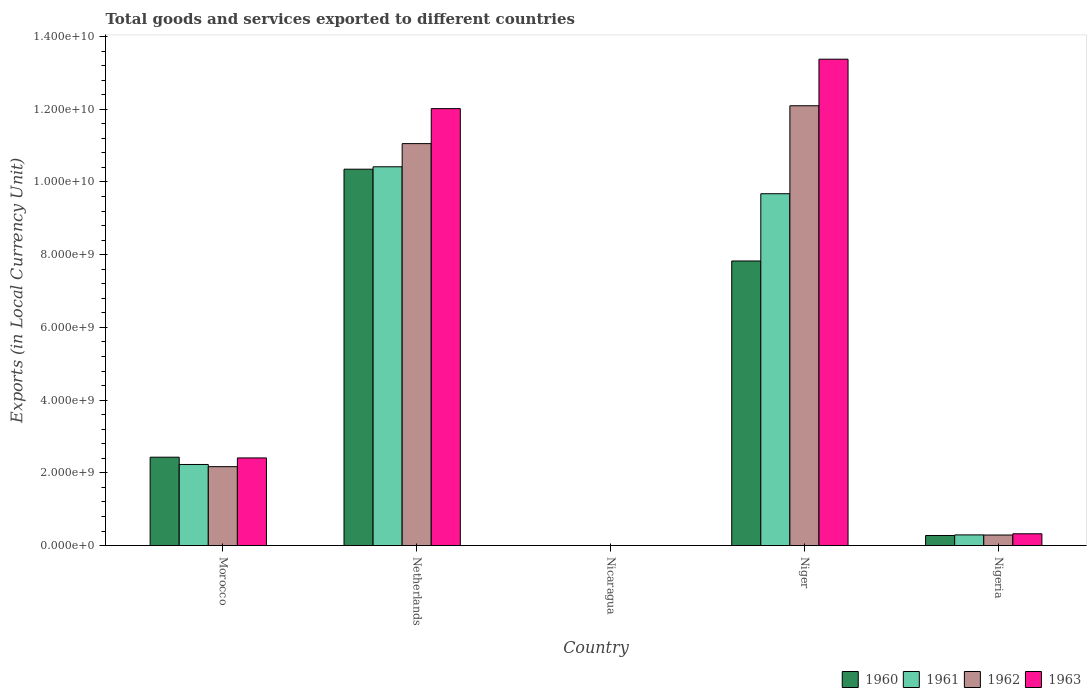How many different coloured bars are there?
Make the answer very short. 4. Are the number of bars per tick equal to the number of legend labels?
Ensure brevity in your answer.  Yes. Are the number of bars on each tick of the X-axis equal?
Ensure brevity in your answer.  Yes. How many bars are there on the 4th tick from the left?
Your response must be concise. 4. How many bars are there on the 3rd tick from the right?
Provide a succinct answer. 4. What is the label of the 5th group of bars from the left?
Offer a very short reply. Nigeria. What is the Amount of goods and services exports in 1961 in Niger?
Give a very brief answer. 9.68e+09. Across all countries, what is the maximum Amount of goods and services exports in 1962?
Ensure brevity in your answer.  1.21e+1. Across all countries, what is the minimum Amount of goods and services exports in 1961?
Make the answer very short. 0.12. In which country was the Amount of goods and services exports in 1963 maximum?
Your response must be concise. Niger. In which country was the Amount of goods and services exports in 1963 minimum?
Your answer should be compact. Nicaragua. What is the total Amount of goods and services exports in 1962 in the graph?
Your response must be concise. 2.56e+1. What is the difference between the Amount of goods and services exports in 1961 in Morocco and that in Nigeria?
Provide a short and direct response. 1.94e+09. What is the difference between the Amount of goods and services exports in 1961 in Netherlands and the Amount of goods and services exports in 1963 in Niger?
Your response must be concise. -2.96e+09. What is the average Amount of goods and services exports in 1961 per country?
Your answer should be very brief. 4.52e+09. What is the difference between the Amount of goods and services exports of/in 1962 and Amount of goods and services exports of/in 1960 in Nigeria?
Your answer should be compact. 1.30e+07. What is the ratio of the Amount of goods and services exports in 1963 in Netherlands to that in Nigeria?
Offer a very short reply. 37.1. Is the Amount of goods and services exports in 1961 in Nicaragua less than that in Niger?
Provide a short and direct response. Yes. What is the difference between the highest and the second highest Amount of goods and services exports in 1963?
Your answer should be compact. -1.36e+09. What is the difference between the highest and the lowest Amount of goods and services exports in 1962?
Provide a succinct answer. 1.21e+1. What does the 3rd bar from the right in Morocco represents?
Make the answer very short. 1961. How many bars are there?
Offer a terse response. 20. Are all the bars in the graph horizontal?
Provide a succinct answer. No. How many countries are there in the graph?
Make the answer very short. 5. What is the difference between two consecutive major ticks on the Y-axis?
Your answer should be compact. 2.00e+09. Are the values on the major ticks of Y-axis written in scientific E-notation?
Your answer should be compact. Yes. Does the graph contain any zero values?
Make the answer very short. No. Does the graph contain grids?
Your response must be concise. No. What is the title of the graph?
Give a very brief answer. Total goods and services exported to different countries. Does "1975" appear as one of the legend labels in the graph?
Offer a terse response. No. What is the label or title of the Y-axis?
Offer a terse response. Exports (in Local Currency Unit). What is the Exports (in Local Currency Unit) in 1960 in Morocco?
Your answer should be compact. 2.43e+09. What is the Exports (in Local Currency Unit) of 1961 in Morocco?
Provide a succinct answer. 2.23e+09. What is the Exports (in Local Currency Unit) of 1962 in Morocco?
Your answer should be compact. 2.17e+09. What is the Exports (in Local Currency Unit) of 1963 in Morocco?
Provide a succinct answer. 2.41e+09. What is the Exports (in Local Currency Unit) of 1960 in Netherlands?
Provide a short and direct response. 1.04e+1. What is the Exports (in Local Currency Unit) of 1961 in Netherlands?
Provide a succinct answer. 1.04e+1. What is the Exports (in Local Currency Unit) of 1962 in Netherlands?
Your response must be concise. 1.11e+1. What is the Exports (in Local Currency Unit) in 1963 in Netherlands?
Your answer should be compact. 1.20e+1. What is the Exports (in Local Currency Unit) in 1960 in Nicaragua?
Provide a succinct answer. 0.11. What is the Exports (in Local Currency Unit) of 1961 in Nicaragua?
Your answer should be very brief. 0.12. What is the Exports (in Local Currency Unit) in 1962 in Nicaragua?
Provide a succinct answer. 0.15. What is the Exports (in Local Currency Unit) in 1963 in Nicaragua?
Offer a terse response. 0.18. What is the Exports (in Local Currency Unit) of 1960 in Niger?
Provide a short and direct response. 7.83e+09. What is the Exports (in Local Currency Unit) of 1961 in Niger?
Your answer should be compact. 9.68e+09. What is the Exports (in Local Currency Unit) in 1962 in Niger?
Your response must be concise. 1.21e+1. What is the Exports (in Local Currency Unit) in 1963 in Niger?
Offer a very short reply. 1.34e+1. What is the Exports (in Local Currency Unit) in 1960 in Nigeria?
Keep it short and to the point. 2.77e+08. What is the Exports (in Local Currency Unit) in 1961 in Nigeria?
Give a very brief answer. 2.93e+08. What is the Exports (in Local Currency Unit) in 1962 in Nigeria?
Your answer should be very brief. 2.90e+08. What is the Exports (in Local Currency Unit) of 1963 in Nigeria?
Your response must be concise. 3.24e+08. Across all countries, what is the maximum Exports (in Local Currency Unit) of 1960?
Your response must be concise. 1.04e+1. Across all countries, what is the maximum Exports (in Local Currency Unit) in 1961?
Offer a very short reply. 1.04e+1. Across all countries, what is the maximum Exports (in Local Currency Unit) of 1962?
Make the answer very short. 1.21e+1. Across all countries, what is the maximum Exports (in Local Currency Unit) in 1963?
Ensure brevity in your answer.  1.34e+1. Across all countries, what is the minimum Exports (in Local Currency Unit) in 1960?
Provide a succinct answer. 0.11. Across all countries, what is the minimum Exports (in Local Currency Unit) of 1961?
Keep it short and to the point. 0.12. Across all countries, what is the minimum Exports (in Local Currency Unit) of 1962?
Offer a terse response. 0.15. Across all countries, what is the minimum Exports (in Local Currency Unit) of 1963?
Offer a terse response. 0.18. What is the total Exports (in Local Currency Unit) of 1960 in the graph?
Ensure brevity in your answer.  2.09e+1. What is the total Exports (in Local Currency Unit) of 1961 in the graph?
Provide a succinct answer. 2.26e+1. What is the total Exports (in Local Currency Unit) in 1962 in the graph?
Make the answer very short. 2.56e+1. What is the total Exports (in Local Currency Unit) of 1963 in the graph?
Offer a terse response. 2.81e+1. What is the difference between the Exports (in Local Currency Unit) in 1960 in Morocco and that in Netherlands?
Provide a succinct answer. -7.92e+09. What is the difference between the Exports (in Local Currency Unit) in 1961 in Morocco and that in Netherlands?
Provide a succinct answer. -8.19e+09. What is the difference between the Exports (in Local Currency Unit) in 1962 in Morocco and that in Netherlands?
Your response must be concise. -8.88e+09. What is the difference between the Exports (in Local Currency Unit) of 1963 in Morocco and that in Netherlands?
Provide a succinct answer. -9.61e+09. What is the difference between the Exports (in Local Currency Unit) of 1960 in Morocco and that in Nicaragua?
Make the answer very short. 2.43e+09. What is the difference between the Exports (in Local Currency Unit) in 1961 in Morocco and that in Nicaragua?
Offer a terse response. 2.23e+09. What is the difference between the Exports (in Local Currency Unit) of 1962 in Morocco and that in Nicaragua?
Keep it short and to the point. 2.17e+09. What is the difference between the Exports (in Local Currency Unit) of 1963 in Morocco and that in Nicaragua?
Offer a very short reply. 2.41e+09. What is the difference between the Exports (in Local Currency Unit) in 1960 in Morocco and that in Niger?
Your response must be concise. -5.40e+09. What is the difference between the Exports (in Local Currency Unit) of 1961 in Morocco and that in Niger?
Ensure brevity in your answer.  -7.45e+09. What is the difference between the Exports (in Local Currency Unit) of 1962 in Morocco and that in Niger?
Ensure brevity in your answer.  -9.92e+09. What is the difference between the Exports (in Local Currency Unit) of 1963 in Morocco and that in Niger?
Ensure brevity in your answer.  -1.10e+1. What is the difference between the Exports (in Local Currency Unit) of 1960 in Morocco and that in Nigeria?
Your answer should be compact. 2.15e+09. What is the difference between the Exports (in Local Currency Unit) of 1961 in Morocco and that in Nigeria?
Give a very brief answer. 1.94e+09. What is the difference between the Exports (in Local Currency Unit) in 1962 in Morocco and that in Nigeria?
Offer a very short reply. 1.88e+09. What is the difference between the Exports (in Local Currency Unit) of 1963 in Morocco and that in Nigeria?
Your answer should be very brief. 2.09e+09. What is the difference between the Exports (in Local Currency Unit) of 1960 in Netherlands and that in Nicaragua?
Make the answer very short. 1.04e+1. What is the difference between the Exports (in Local Currency Unit) in 1961 in Netherlands and that in Nicaragua?
Make the answer very short. 1.04e+1. What is the difference between the Exports (in Local Currency Unit) of 1962 in Netherlands and that in Nicaragua?
Give a very brief answer. 1.11e+1. What is the difference between the Exports (in Local Currency Unit) of 1963 in Netherlands and that in Nicaragua?
Keep it short and to the point. 1.20e+1. What is the difference between the Exports (in Local Currency Unit) of 1960 in Netherlands and that in Niger?
Keep it short and to the point. 2.52e+09. What is the difference between the Exports (in Local Currency Unit) of 1961 in Netherlands and that in Niger?
Offer a very short reply. 7.41e+08. What is the difference between the Exports (in Local Currency Unit) of 1962 in Netherlands and that in Niger?
Your answer should be very brief. -1.04e+09. What is the difference between the Exports (in Local Currency Unit) of 1963 in Netherlands and that in Niger?
Your answer should be very brief. -1.36e+09. What is the difference between the Exports (in Local Currency Unit) in 1960 in Netherlands and that in Nigeria?
Ensure brevity in your answer.  1.01e+1. What is the difference between the Exports (in Local Currency Unit) of 1961 in Netherlands and that in Nigeria?
Give a very brief answer. 1.01e+1. What is the difference between the Exports (in Local Currency Unit) of 1962 in Netherlands and that in Nigeria?
Your response must be concise. 1.08e+1. What is the difference between the Exports (in Local Currency Unit) in 1963 in Netherlands and that in Nigeria?
Provide a short and direct response. 1.17e+1. What is the difference between the Exports (in Local Currency Unit) of 1960 in Nicaragua and that in Niger?
Ensure brevity in your answer.  -7.83e+09. What is the difference between the Exports (in Local Currency Unit) of 1961 in Nicaragua and that in Niger?
Make the answer very short. -9.68e+09. What is the difference between the Exports (in Local Currency Unit) in 1962 in Nicaragua and that in Niger?
Give a very brief answer. -1.21e+1. What is the difference between the Exports (in Local Currency Unit) of 1963 in Nicaragua and that in Niger?
Your response must be concise. -1.34e+1. What is the difference between the Exports (in Local Currency Unit) of 1960 in Nicaragua and that in Nigeria?
Provide a succinct answer. -2.77e+08. What is the difference between the Exports (in Local Currency Unit) in 1961 in Nicaragua and that in Nigeria?
Offer a terse response. -2.93e+08. What is the difference between the Exports (in Local Currency Unit) of 1962 in Nicaragua and that in Nigeria?
Keep it short and to the point. -2.90e+08. What is the difference between the Exports (in Local Currency Unit) of 1963 in Nicaragua and that in Nigeria?
Keep it short and to the point. -3.24e+08. What is the difference between the Exports (in Local Currency Unit) in 1960 in Niger and that in Nigeria?
Your answer should be compact. 7.55e+09. What is the difference between the Exports (in Local Currency Unit) in 1961 in Niger and that in Nigeria?
Keep it short and to the point. 9.38e+09. What is the difference between the Exports (in Local Currency Unit) of 1962 in Niger and that in Nigeria?
Offer a very short reply. 1.18e+1. What is the difference between the Exports (in Local Currency Unit) of 1963 in Niger and that in Nigeria?
Provide a succinct answer. 1.31e+1. What is the difference between the Exports (in Local Currency Unit) of 1960 in Morocco and the Exports (in Local Currency Unit) of 1961 in Netherlands?
Offer a very short reply. -7.99e+09. What is the difference between the Exports (in Local Currency Unit) of 1960 in Morocco and the Exports (in Local Currency Unit) of 1962 in Netherlands?
Your response must be concise. -8.62e+09. What is the difference between the Exports (in Local Currency Unit) of 1960 in Morocco and the Exports (in Local Currency Unit) of 1963 in Netherlands?
Provide a succinct answer. -9.59e+09. What is the difference between the Exports (in Local Currency Unit) in 1961 in Morocco and the Exports (in Local Currency Unit) in 1962 in Netherlands?
Offer a very short reply. -8.82e+09. What is the difference between the Exports (in Local Currency Unit) in 1961 in Morocco and the Exports (in Local Currency Unit) in 1963 in Netherlands?
Offer a very short reply. -9.79e+09. What is the difference between the Exports (in Local Currency Unit) in 1962 in Morocco and the Exports (in Local Currency Unit) in 1963 in Netherlands?
Offer a very short reply. -9.85e+09. What is the difference between the Exports (in Local Currency Unit) of 1960 in Morocco and the Exports (in Local Currency Unit) of 1961 in Nicaragua?
Provide a short and direct response. 2.43e+09. What is the difference between the Exports (in Local Currency Unit) in 1960 in Morocco and the Exports (in Local Currency Unit) in 1962 in Nicaragua?
Give a very brief answer. 2.43e+09. What is the difference between the Exports (in Local Currency Unit) in 1960 in Morocco and the Exports (in Local Currency Unit) in 1963 in Nicaragua?
Keep it short and to the point. 2.43e+09. What is the difference between the Exports (in Local Currency Unit) of 1961 in Morocco and the Exports (in Local Currency Unit) of 1962 in Nicaragua?
Your answer should be very brief. 2.23e+09. What is the difference between the Exports (in Local Currency Unit) in 1961 in Morocco and the Exports (in Local Currency Unit) in 1963 in Nicaragua?
Offer a very short reply. 2.23e+09. What is the difference between the Exports (in Local Currency Unit) in 1962 in Morocco and the Exports (in Local Currency Unit) in 1963 in Nicaragua?
Your answer should be very brief. 2.17e+09. What is the difference between the Exports (in Local Currency Unit) of 1960 in Morocco and the Exports (in Local Currency Unit) of 1961 in Niger?
Give a very brief answer. -7.25e+09. What is the difference between the Exports (in Local Currency Unit) of 1960 in Morocco and the Exports (in Local Currency Unit) of 1962 in Niger?
Provide a succinct answer. -9.66e+09. What is the difference between the Exports (in Local Currency Unit) of 1960 in Morocco and the Exports (in Local Currency Unit) of 1963 in Niger?
Offer a very short reply. -1.09e+1. What is the difference between the Exports (in Local Currency Unit) of 1961 in Morocco and the Exports (in Local Currency Unit) of 1962 in Niger?
Provide a succinct answer. -9.86e+09. What is the difference between the Exports (in Local Currency Unit) of 1961 in Morocco and the Exports (in Local Currency Unit) of 1963 in Niger?
Keep it short and to the point. -1.11e+1. What is the difference between the Exports (in Local Currency Unit) in 1962 in Morocco and the Exports (in Local Currency Unit) in 1963 in Niger?
Provide a succinct answer. -1.12e+1. What is the difference between the Exports (in Local Currency Unit) of 1960 in Morocco and the Exports (in Local Currency Unit) of 1961 in Nigeria?
Your answer should be very brief. 2.14e+09. What is the difference between the Exports (in Local Currency Unit) in 1960 in Morocco and the Exports (in Local Currency Unit) in 1962 in Nigeria?
Ensure brevity in your answer.  2.14e+09. What is the difference between the Exports (in Local Currency Unit) of 1960 in Morocco and the Exports (in Local Currency Unit) of 1963 in Nigeria?
Your answer should be very brief. 2.11e+09. What is the difference between the Exports (in Local Currency Unit) of 1961 in Morocco and the Exports (in Local Currency Unit) of 1962 in Nigeria?
Make the answer very short. 1.94e+09. What is the difference between the Exports (in Local Currency Unit) of 1961 in Morocco and the Exports (in Local Currency Unit) of 1963 in Nigeria?
Offer a very short reply. 1.91e+09. What is the difference between the Exports (in Local Currency Unit) in 1962 in Morocco and the Exports (in Local Currency Unit) in 1963 in Nigeria?
Your answer should be compact. 1.85e+09. What is the difference between the Exports (in Local Currency Unit) in 1960 in Netherlands and the Exports (in Local Currency Unit) in 1961 in Nicaragua?
Provide a short and direct response. 1.04e+1. What is the difference between the Exports (in Local Currency Unit) of 1960 in Netherlands and the Exports (in Local Currency Unit) of 1962 in Nicaragua?
Provide a succinct answer. 1.04e+1. What is the difference between the Exports (in Local Currency Unit) in 1960 in Netherlands and the Exports (in Local Currency Unit) in 1963 in Nicaragua?
Provide a short and direct response. 1.04e+1. What is the difference between the Exports (in Local Currency Unit) in 1961 in Netherlands and the Exports (in Local Currency Unit) in 1962 in Nicaragua?
Ensure brevity in your answer.  1.04e+1. What is the difference between the Exports (in Local Currency Unit) of 1961 in Netherlands and the Exports (in Local Currency Unit) of 1963 in Nicaragua?
Your response must be concise. 1.04e+1. What is the difference between the Exports (in Local Currency Unit) of 1962 in Netherlands and the Exports (in Local Currency Unit) of 1963 in Nicaragua?
Provide a short and direct response. 1.11e+1. What is the difference between the Exports (in Local Currency Unit) of 1960 in Netherlands and the Exports (in Local Currency Unit) of 1961 in Niger?
Provide a succinct answer. 6.75e+08. What is the difference between the Exports (in Local Currency Unit) of 1960 in Netherlands and the Exports (in Local Currency Unit) of 1962 in Niger?
Make the answer very short. -1.74e+09. What is the difference between the Exports (in Local Currency Unit) of 1960 in Netherlands and the Exports (in Local Currency Unit) of 1963 in Niger?
Give a very brief answer. -3.02e+09. What is the difference between the Exports (in Local Currency Unit) of 1961 in Netherlands and the Exports (in Local Currency Unit) of 1962 in Niger?
Your response must be concise. -1.68e+09. What is the difference between the Exports (in Local Currency Unit) in 1961 in Netherlands and the Exports (in Local Currency Unit) in 1963 in Niger?
Make the answer very short. -2.96e+09. What is the difference between the Exports (in Local Currency Unit) in 1962 in Netherlands and the Exports (in Local Currency Unit) in 1963 in Niger?
Provide a succinct answer. -2.32e+09. What is the difference between the Exports (in Local Currency Unit) of 1960 in Netherlands and the Exports (in Local Currency Unit) of 1961 in Nigeria?
Your response must be concise. 1.01e+1. What is the difference between the Exports (in Local Currency Unit) in 1960 in Netherlands and the Exports (in Local Currency Unit) in 1962 in Nigeria?
Your answer should be compact. 1.01e+1. What is the difference between the Exports (in Local Currency Unit) in 1960 in Netherlands and the Exports (in Local Currency Unit) in 1963 in Nigeria?
Make the answer very short. 1.00e+1. What is the difference between the Exports (in Local Currency Unit) in 1961 in Netherlands and the Exports (in Local Currency Unit) in 1962 in Nigeria?
Give a very brief answer. 1.01e+1. What is the difference between the Exports (in Local Currency Unit) of 1961 in Netherlands and the Exports (in Local Currency Unit) of 1963 in Nigeria?
Offer a very short reply. 1.01e+1. What is the difference between the Exports (in Local Currency Unit) in 1962 in Netherlands and the Exports (in Local Currency Unit) in 1963 in Nigeria?
Make the answer very short. 1.07e+1. What is the difference between the Exports (in Local Currency Unit) in 1960 in Nicaragua and the Exports (in Local Currency Unit) in 1961 in Niger?
Provide a succinct answer. -9.68e+09. What is the difference between the Exports (in Local Currency Unit) of 1960 in Nicaragua and the Exports (in Local Currency Unit) of 1962 in Niger?
Offer a very short reply. -1.21e+1. What is the difference between the Exports (in Local Currency Unit) of 1960 in Nicaragua and the Exports (in Local Currency Unit) of 1963 in Niger?
Your answer should be compact. -1.34e+1. What is the difference between the Exports (in Local Currency Unit) of 1961 in Nicaragua and the Exports (in Local Currency Unit) of 1962 in Niger?
Provide a short and direct response. -1.21e+1. What is the difference between the Exports (in Local Currency Unit) in 1961 in Nicaragua and the Exports (in Local Currency Unit) in 1963 in Niger?
Provide a succinct answer. -1.34e+1. What is the difference between the Exports (in Local Currency Unit) of 1962 in Nicaragua and the Exports (in Local Currency Unit) of 1963 in Niger?
Your answer should be compact. -1.34e+1. What is the difference between the Exports (in Local Currency Unit) of 1960 in Nicaragua and the Exports (in Local Currency Unit) of 1961 in Nigeria?
Ensure brevity in your answer.  -2.93e+08. What is the difference between the Exports (in Local Currency Unit) of 1960 in Nicaragua and the Exports (in Local Currency Unit) of 1962 in Nigeria?
Your answer should be compact. -2.90e+08. What is the difference between the Exports (in Local Currency Unit) of 1960 in Nicaragua and the Exports (in Local Currency Unit) of 1963 in Nigeria?
Offer a very short reply. -3.24e+08. What is the difference between the Exports (in Local Currency Unit) in 1961 in Nicaragua and the Exports (in Local Currency Unit) in 1962 in Nigeria?
Your answer should be very brief. -2.90e+08. What is the difference between the Exports (in Local Currency Unit) in 1961 in Nicaragua and the Exports (in Local Currency Unit) in 1963 in Nigeria?
Give a very brief answer. -3.24e+08. What is the difference between the Exports (in Local Currency Unit) of 1962 in Nicaragua and the Exports (in Local Currency Unit) of 1963 in Nigeria?
Ensure brevity in your answer.  -3.24e+08. What is the difference between the Exports (in Local Currency Unit) in 1960 in Niger and the Exports (in Local Currency Unit) in 1961 in Nigeria?
Give a very brief answer. 7.53e+09. What is the difference between the Exports (in Local Currency Unit) in 1960 in Niger and the Exports (in Local Currency Unit) in 1962 in Nigeria?
Offer a very short reply. 7.54e+09. What is the difference between the Exports (in Local Currency Unit) in 1960 in Niger and the Exports (in Local Currency Unit) in 1963 in Nigeria?
Give a very brief answer. 7.50e+09. What is the difference between the Exports (in Local Currency Unit) in 1961 in Niger and the Exports (in Local Currency Unit) in 1962 in Nigeria?
Provide a succinct answer. 9.39e+09. What is the difference between the Exports (in Local Currency Unit) of 1961 in Niger and the Exports (in Local Currency Unit) of 1963 in Nigeria?
Provide a succinct answer. 9.35e+09. What is the difference between the Exports (in Local Currency Unit) of 1962 in Niger and the Exports (in Local Currency Unit) of 1963 in Nigeria?
Provide a succinct answer. 1.18e+1. What is the average Exports (in Local Currency Unit) in 1960 per country?
Make the answer very short. 4.18e+09. What is the average Exports (in Local Currency Unit) in 1961 per country?
Your response must be concise. 4.52e+09. What is the average Exports (in Local Currency Unit) of 1962 per country?
Give a very brief answer. 5.12e+09. What is the average Exports (in Local Currency Unit) of 1963 per country?
Make the answer very short. 5.63e+09. What is the difference between the Exports (in Local Currency Unit) in 1960 and Exports (in Local Currency Unit) in 1962 in Morocco?
Provide a short and direct response. 2.60e+08. What is the difference between the Exports (in Local Currency Unit) in 1960 and Exports (in Local Currency Unit) in 1963 in Morocco?
Offer a very short reply. 2.00e+07. What is the difference between the Exports (in Local Currency Unit) in 1961 and Exports (in Local Currency Unit) in 1962 in Morocco?
Your answer should be compact. 6.00e+07. What is the difference between the Exports (in Local Currency Unit) of 1961 and Exports (in Local Currency Unit) of 1963 in Morocco?
Your answer should be compact. -1.80e+08. What is the difference between the Exports (in Local Currency Unit) in 1962 and Exports (in Local Currency Unit) in 1963 in Morocco?
Your response must be concise. -2.40e+08. What is the difference between the Exports (in Local Currency Unit) in 1960 and Exports (in Local Currency Unit) in 1961 in Netherlands?
Provide a short and direct response. -6.60e+07. What is the difference between the Exports (in Local Currency Unit) in 1960 and Exports (in Local Currency Unit) in 1962 in Netherlands?
Your answer should be very brief. -7.03e+08. What is the difference between the Exports (in Local Currency Unit) in 1960 and Exports (in Local Currency Unit) in 1963 in Netherlands?
Your answer should be very brief. -1.67e+09. What is the difference between the Exports (in Local Currency Unit) in 1961 and Exports (in Local Currency Unit) in 1962 in Netherlands?
Give a very brief answer. -6.37e+08. What is the difference between the Exports (in Local Currency Unit) in 1961 and Exports (in Local Currency Unit) in 1963 in Netherlands?
Make the answer very short. -1.60e+09. What is the difference between the Exports (in Local Currency Unit) of 1962 and Exports (in Local Currency Unit) of 1963 in Netherlands?
Give a very brief answer. -9.62e+08. What is the difference between the Exports (in Local Currency Unit) of 1960 and Exports (in Local Currency Unit) of 1961 in Nicaragua?
Provide a succinct answer. -0.01. What is the difference between the Exports (in Local Currency Unit) in 1960 and Exports (in Local Currency Unit) in 1962 in Nicaragua?
Provide a succinct answer. -0.04. What is the difference between the Exports (in Local Currency Unit) of 1960 and Exports (in Local Currency Unit) of 1963 in Nicaragua?
Your response must be concise. -0.07. What is the difference between the Exports (in Local Currency Unit) of 1961 and Exports (in Local Currency Unit) of 1962 in Nicaragua?
Give a very brief answer. -0.03. What is the difference between the Exports (in Local Currency Unit) in 1961 and Exports (in Local Currency Unit) in 1963 in Nicaragua?
Offer a terse response. -0.06. What is the difference between the Exports (in Local Currency Unit) in 1962 and Exports (in Local Currency Unit) in 1963 in Nicaragua?
Make the answer very short. -0.03. What is the difference between the Exports (in Local Currency Unit) in 1960 and Exports (in Local Currency Unit) in 1961 in Niger?
Offer a terse response. -1.85e+09. What is the difference between the Exports (in Local Currency Unit) in 1960 and Exports (in Local Currency Unit) in 1962 in Niger?
Your response must be concise. -4.27e+09. What is the difference between the Exports (in Local Currency Unit) in 1960 and Exports (in Local Currency Unit) in 1963 in Niger?
Your response must be concise. -5.55e+09. What is the difference between the Exports (in Local Currency Unit) in 1961 and Exports (in Local Currency Unit) in 1962 in Niger?
Provide a succinct answer. -2.42e+09. What is the difference between the Exports (in Local Currency Unit) in 1961 and Exports (in Local Currency Unit) in 1963 in Niger?
Offer a terse response. -3.70e+09. What is the difference between the Exports (in Local Currency Unit) of 1962 and Exports (in Local Currency Unit) of 1963 in Niger?
Ensure brevity in your answer.  -1.28e+09. What is the difference between the Exports (in Local Currency Unit) of 1960 and Exports (in Local Currency Unit) of 1961 in Nigeria?
Provide a short and direct response. -1.61e+07. What is the difference between the Exports (in Local Currency Unit) of 1960 and Exports (in Local Currency Unit) of 1962 in Nigeria?
Provide a succinct answer. -1.30e+07. What is the difference between the Exports (in Local Currency Unit) of 1960 and Exports (in Local Currency Unit) of 1963 in Nigeria?
Provide a short and direct response. -4.69e+07. What is the difference between the Exports (in Local Currency Unit) of 1961 and Exports (in Local Currency Unit) of 1962 in Nigeria?
Provide a succinct answer. 3.12e+06. What is the difference between the Exports (in Local Currency Unit) in 1961 and Exports (in Local Currency Unit) in 1963 in Nigeria?
Give a very brief answer. -3.08e+07. What is the difference between the Exports (in Local Currency Unit) of 1962 and Exports (in Local Currency Unit) of 1963 in Nigeria?
Provide a short and direct response. -3.40e+07. What is the ratio of the Exports (in Local Currency Unit) in 1960 in Morocco to that in Netherlands?
Your response must be concise. 0.23. What is the ratio of the Exports (in Local Currency Unit) of 1961 in Morocco to that in Netherlands?
Give a very brief answer. 0.21. What is the ratio of the Exports (in Local Currency Unit) in 1962 in Morocco to that in Netherlands?
Make the answer very short. 0.2. What is the ratio of the Exports (in Local Currency Unit) of 1963 in Morocco to that in Netherlands?
Offer a terse response. 0.2. What is the ratio of the Exports (in Local Currency Unit) of 1960 in Morocco to that in Nicaragua?
Provide a short and direct response. 2.19e+1. What is the ratio of the Exports (in Local Currency Unit) of 1961 in Morocco to that in Nicaragua?
Offer a terse response. 1.89e+1. What is the ratio of the Exports (in Local Currency Unit) of 1962 in Morocco to that in Nicaragua?
Your answer should be very brief. 1.47e+1. What is the ratio of the Exports (in Local Currency Unit) of 1963 in Morocco to that in Nicaragua?
Your answer should be very brief. 1.36e+1. What is the ratio of the Exports (in Local Currency Unit) in 1960 in Morocco to that in Niger?
Give a very brief answer. 0.31. What is the ratio of the Exports (in Local Currency Unit) in 1961 in Morocco to that in Niger?
Your response must be concise. 0.23. What is the ratio of the Exports (in Local Currency Unit) in 1962 in Morocco to that in Niger?
Provide a succinct answer. 0.18. What is the ratio of the Exports (in Local Currency Unit) of 1963 in Morocco to that in Niger?
Your answer should be compact. 0.18. What is the ratio of the Exports (in Local Currency Unit) in 1960 in Morocco to that in Nigeria?
Offer a very short reply. 8.77. What is the ratio of the Exports (in Local Currency Unit) of 1961 in Morocco to that in Nigeria?
Your response must be concise. 7.61. What is the ratio of the Exports (in Local Currency Unit) of 1962 in Morocco to that in Nigeria?
Your answer should be compact. 7.48. What is the ratio of the Exports (in Local Currency Unit) of 1963 in Morocco to that in Nigeria?
Make the answer very short. 7.44. What is the ratio of the Exports (in Local Currency Unit) of 1960 in Netherlands to that in Nicaragua?
Offer a terse response. 9.31e+1. What is the ratio of the Exports (in Local Currency Unit) in 1961 in Netherlands to that in Nicaragua?
Ensure brevity in your answer.  8.81e+1. What is the ratio of the Exports (in Local Currency Unit) of 1962 in Netherlands to that in Nicaragua?
Your answer should be very brief. 7.51e+1. What is the ratio of the Exports (in Local Currency Unit) in 1963 in Netherlands to that in Nicaragua?
Your response must be concise. 6.78e+1. What is the ratio of the Exports (in Local Currency Unit) of 1960 in Netherlands to that in Niger?
Your answer should be very brief. 1.32. What is the ratio of the Exports (in Local Currency Unit) in 1961 in Netherlands to that in Niger?
Offer a terse response. 1.08. What is the ratio of the Exports (in Local Currency Unit) of 1962 in Netherlands to that in Niger?
Your response must be concise. 0.91. What is the ratio of the Exports (in Local Currency Unit) of 1963 in Netherlands to that in Niger?
Offer a terse response. 0.9. What is the ratio of the Exports (in Local Currency Unit) of 1960 in Netherlands to that in Nigeria?
Your response must be concise. 37.37. What is the ratio of the Exports (in Local Currency Unit) in 1961 in Netherlands to that in Nigeria?
Ensure brevity in your answer.  35.54. What is the ratio of the Exports (in Local Currency Unit) in 1962 in Netherlands to that in Nigeria?
Ensure brevity in your answer.  38.12. What is the ratio of the Exports (in Local Currency Unit) of 1963 in Netherlands to that in Nigeria?
Offer a terse response. 37.1. What is the ratio of the Exports (in Local Currency Unit) in 1960 in Nicaragua to that in Niger?
Make the answer very short. 0. What is the ratio of the Exports (in Local Currency Unit) in 1963 in Nicaragua to that in Niger?
Your response must be concise. 0. What is the ratio of the Exports (in Local Currency Unit) in 1961 in Nicaragua to that in Nigeria?
Provide a short and direct response. 0. What is the ratio of the Exports (in Local Currency Unit) of 1962 in Nicaragua to that in Nigeria?
Your answer should be compact. 0. What is the ratio of the Exports (in Local Currency Unit) of 1963 in Nicaragua to that in Nigeria?
Give a very brief answer. 0. What is the ratio of the Exports (in Local Currency Unit) in 1960 in Niger to that in Nigeria?
Offer a very short reply. 28.25. What is the ratio of the Exports (in Local Currency Unit) in 1961 in Niger to that in Nigeria?
Make the answer very short. 33.01. What is the ratio of the Exports (in Local Currency Unit) of 1962 in Niger to that in Nigeria?
Provide a short and direct response. 41.71. What is the ratio of the Exports (in Local Currency Unit) in 1963 in Niger to that in Nigeria?
Offer a very short reply. 41.29. What is the difference between the highest and the second highest Exports (in Local Currency Unit) of 1960?
Ensure brevity in your answer.  2.52e+09. What is the difference between the highest and the second highest Exports (in Local Currency Unit) of 1961?
Offer a very short reply. 7.41e+08. What is the difference between the highest and the second highest Exports (in Local Currency Unit) in 1962?
Ensure brevity in your answer.  1.04e+09. What is the difference between the highest and the second highest Exports (in Local Currency Unit) in 1963?
Your response must be concise. 1.36e+09. What is the difference between the highest and the lowest Exports (in Local Currency Unit) in 1960?
Your answer should be compact. 1.04e+1. What is the difference between the highest and the lowest Exports (in Local Currency Unit) in 1961?
Provide a short and direct response. 1.04e+1. What is the difference between the highest and the lowest Exports (in Local Currency Unit) in 1962?
Make the answer very short. 1.21e+1. What is the difference between the highest and the lowest Exports (in Local Currency Unit) in 1963?
Provide a succinct answer. 1.34e+1. 